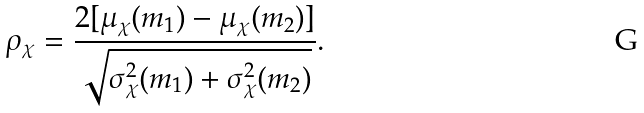Convert formula to latex. <formula><loc_0><loc_0><loc_500><loc_500>\rho _ { \chi } = \frac { 2 [ \mu _ { \chi } ( m _ { 1 } ) - \mu _ { \chi } ( m _ { 2 } ) ] } { \sqrt { \sigma _ { \chi } ^ { 2 } ( m _ { 1 } ) + \sigma _ { \chi } ^ { 2 } ( m _ { 2 } ) } } .</formula> 